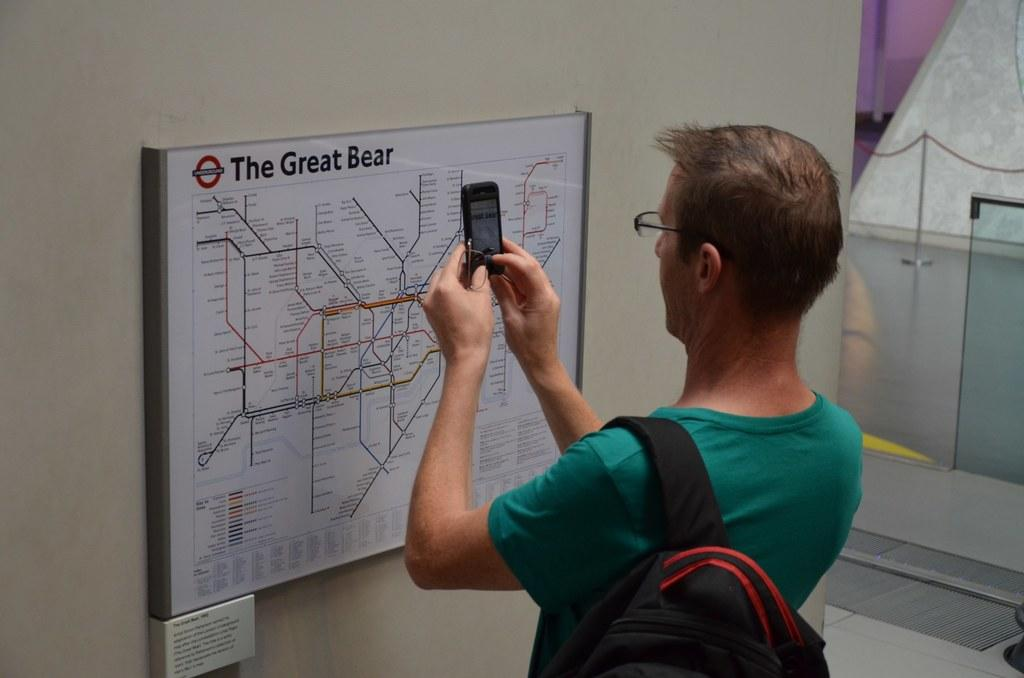<image>
Describe the image concisely. A man photographs a map of the Great Bear. 